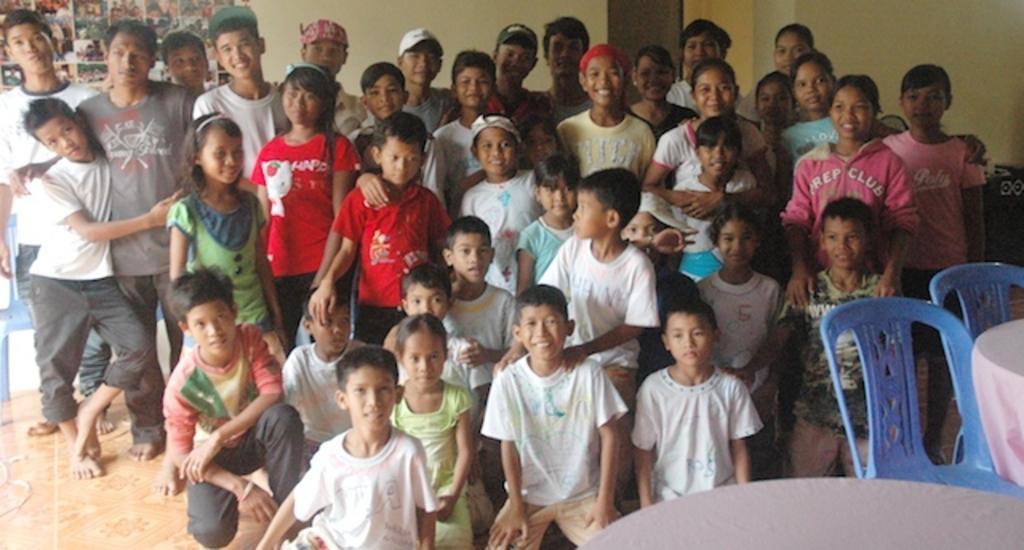How would you summarize this image in a sentence or two? In this picture we can see some people standing here, in the background there is a wall, on the right side there are two chairs and a table, we can see photos at the left top of the picture. 